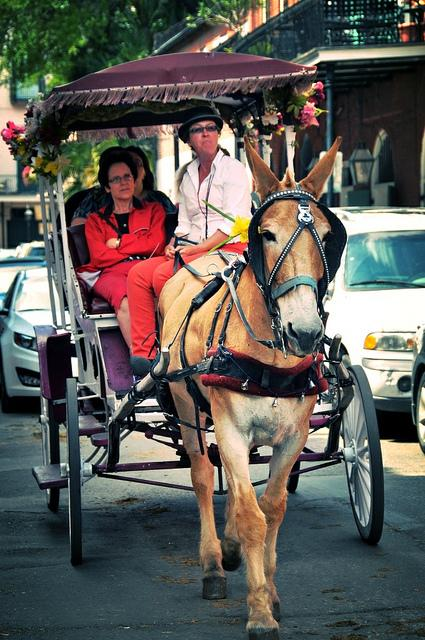What is this horse being used for?

Choices:
A) consumption
B) transportation
C) companionship
D) riding transportation 